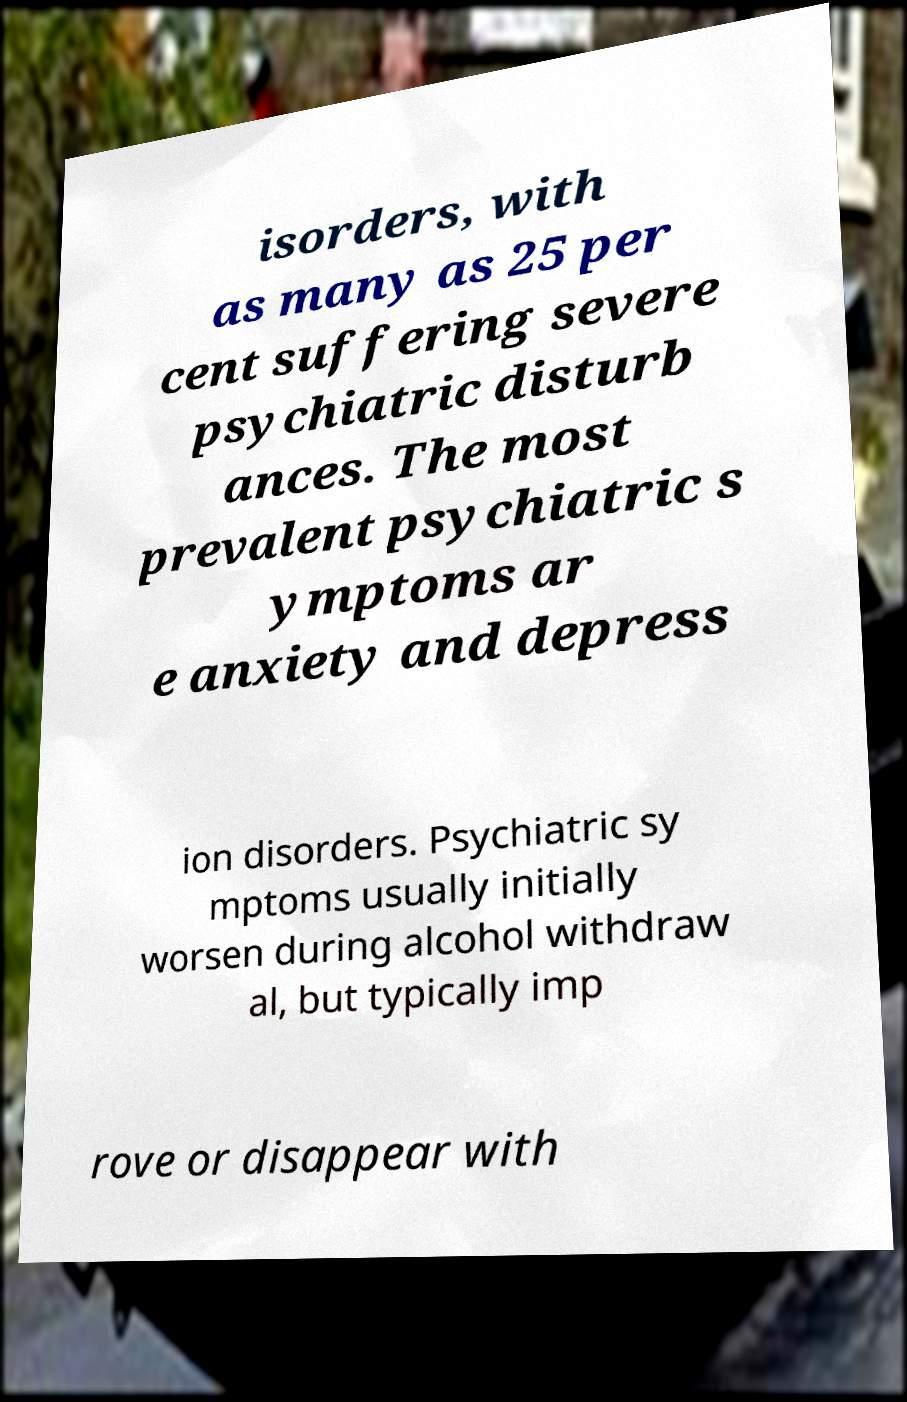Can you accurately transcribe the text from the provided image for me? isorders, with as many as 25 per cent suffering severe psychiatric disturb ances. The most prevalent psychiatric s ymptoms ar e anxiety and depress ion disorders. Psychiatric sy mptoms usually initially worsen during alcohol withdraw al, but typically imp rove or disappear with 